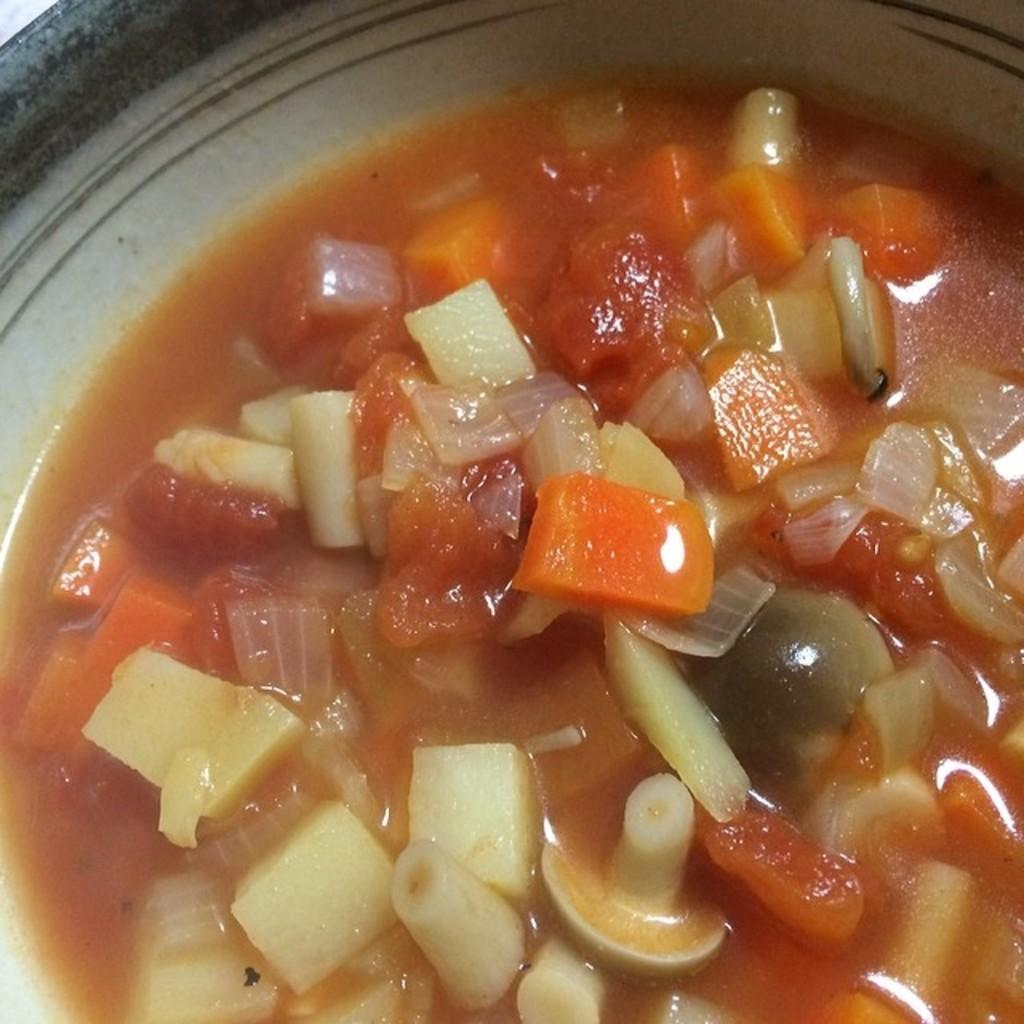What is present in the image? There is a bowl in the image. What is inside the bowl? The bowl contains a food item. What type of food is in the bowl? The food item is carrots. How many girls are playing with trucks in the image? There are no girls or trucks present in the image. Are there any men visible in the image? There is no mention of men in the provided facts, and therefore we cannot determine if any are present in the image. 